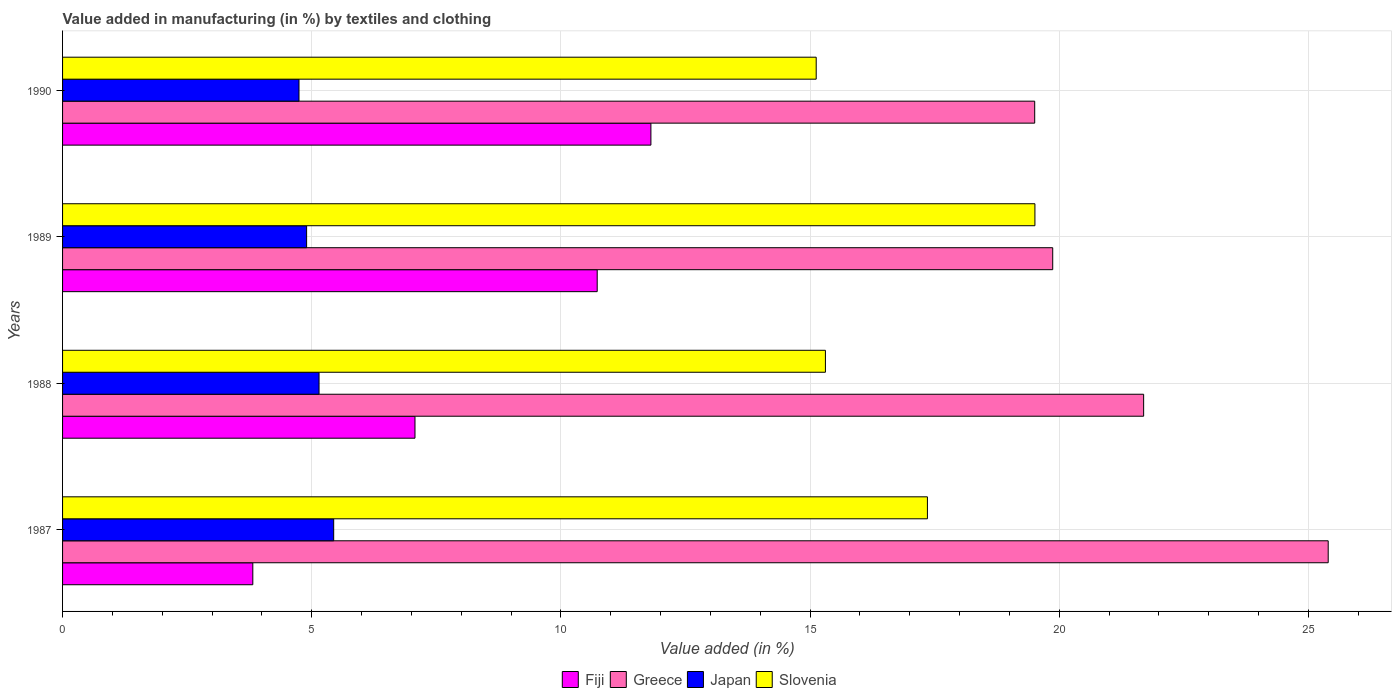How many different coloured bars are there?
Your answer should be compact. 4. How many groups of bars are there?
Your answer should be compact. 4. Are the number of bars per tick equal to the number of legend labels?
Your answer should be compact. Yes. Are the number of bars on each tick of the Y-axis equal?
Ensure brevity in your answer.  Yes. How many bars are there on the 1st tick from the top?
Your answer should be very brief. 4. How many bars are there on the 1st tick from the bottom?
Offer a terse response. 4. In how many cases, is the number of bars for a given year not equal to the number of legend labels?
Ensure brevity in your answer.  0. What is the percentage of value added in manufacturing by textiles and clothing in Fiji in 1988?
Offer a terse response. 7.07. Across all years, what is the maximum percentage of value added in manufacturing by textiles and clothing in Fiji?
Ensure brevity in your answer.  11.81. Across all years, what is the minimum percentage of value added in manufacturing by textiles and clothing in Greece?
Your response must be concise. 19.51. In which year was the percentage of value added in manufacturing by textiles and clothing in Slovenia minimum?
Make the answer very short. 1990. What is the total percentage of value added in manufacturing by textiles and clothing in Fiji in the graph?
Offer a very short reply. 33.42. What is the difference between the percentage of value added in manufacturing by textiles and clothing in Greece in 1987 and that in 1988?
Your response must be concise. 3.7. What is the difference between the percentage of value added in manufacturing by textiles and clothing in Japan in 1987 and the percentage of value added in manufacturing by textiles and clothing in Greece in 1989?
Your answer should be very brief. -14.43. What is the average percentage of value added in manufacturing by textiles and clothing in Slovenia per year?
Make the answer very short. 16.82. In the year 1987, what is the difference between the percentage of value added in manufacturing by textiles and clothing in Greece and percentage of value added in manufacturing by textiles and clothing in Slovenia?
Ensure brevity in your answer.  8.04. What is the ratio of the percentage of value added in manufacturing by textiles and clothing in Slovenia in 1987 to that in 1989?
Your answer should be very brief. 0.89. Is the percentage of value added in manufacturing by textiles and clothing in Greece in 1987 less than that in 1988?
Give a very brief answer. No. What is the difference between the highest and the second highest percentage of value added in manufacturing by textiles and clothing in Fiji?
Ensure brevity in your answer.  1.08. What is the difference between the highest and the lowest percentage of value added in manufacturing by textiles and clothing in Greece?
Make the answer very short. 5.89. What does the 1st bar from the top in 1987 represents?
Offer a terse response. Slovenia. What does the 1st bar from the bottom in 1988 represents?
Provide a short and direct response. Fiji. Is it the case that in every year, the sum of the percentage of value added in manufacturing by textiles and clothing in Fiji and percentage of value added in manufacturing by textiles and clothing in Japan is greater than the percentage of value added in manufacturing by textiles and clothing in Greece?
Offer a very short reply. No. Are all the bars in the graph horizontal?
Your answer should be compact. Yes. How many years are there in the graph?
Provide a short and direct response. 4. Does the graph contain any zero values?
Provide a succinct answer. No. Does the graph contain grids?
Ensure brevity in your answer.  Yes. How are the legend labels stacked?
Keep it short and to the point. Horizontal. What is the title of the graph?
Keep it short and to the point. Value added in manufacturing (in %) by textiles and clothing. Does "Iceland" appear as one of the legend labels in the graph?
Offer a terse response. No. What is the label or title of the X-axis?
Ensure brevity in your answer.  Value added (in %). What is the label or title of the Y-axis?
Offer a terse response. Years. What is the Value added (in %) in Fiji in 1987?
Keep it short and to the point. 3.82. What is the Value added (in %) in Greece in 1987?
Your answer should be very brief. 25.4. What is the Value added (in %) of Japan in 1987?
Provide a short and direct response. 5.44. What is the Value added (in %) of Slovenia in 1987?
Give a very brief answer. 17.35. What is the Value added (in %) in Fiji in 1988?
Keep it short and to the point. 7.07. What is the Value added (in %) of Greece in 1988?
Provide a short and direct response. 21.69. What is the Value added (in %) in Japan in 1988?
Make the answer very short. 5.15. What is the Value added (in %) in Slovenia in 1988?
Your answer should be compact. 15.31. What is the Value added (in %) of Fiji in 1989?
Your answer should be very brief. 10.73. What is the Value added (in %) of Greece in 1989?
Your answer should be very brief. 19.87. What is the Value added (in %) of Japan in 1989?
Your answer should be compact. 4.9. What is the Value added (in %) in Slovenia in 1989?
Offer a terse response. 19.51. What is the Value added (in %) in Fiji in 1990?
Make the answer very short. 11.81. What is the Value added (in %) of Greece in 1990?
Offer a terse response. 19.51. What is the Value added (in %) in Japan in 1990?
Your answer should be very brief. 4.74. What is the Value added (in %) of Slovenia in 1990?
Offer a very short reply. 15.12. Across all years, what is the maximum Value added (in %) of Fiji?
Keep it short and to the point. 11.81. Across all years, what is the maximum Value added (in %) in Greece?
Keep it short and to the point. 25.4. Across all years, what is the maximum Value added (in %) in Japan?
Give a very brief answer. 5.44. Across all years, what is the maximum Value added (in %) in Slovenia?
Offer a terse response. 19.51. Across all years, what is the minimum Value added (in %) in Fiji?
Give a very brief answer. 3.82. Across all years, what is the minimum Value added (in %) in Greece?
Make the answer very short. 19.51. Across all years, what is the minimum Value added (in %) in Japan?
Provide a short and direct response. 4.74. Across all years, what is the minimum Value added (in %) of Slovenia?
Provide a short and direct response. 15.12. What is the total Value added (in %) in Fiji in the graph?
Your answer should be very brief. 33.42. What is the total Value added (in %) of Greece in the graph?
Your answer should be very brief. 86.47. What is the total Value added (in %) of Japan in the graph?
Offer a very short reply. 20.23. What is the total Value added (in %) of Slovenia in the graph?
Keep it short and to the point. 67.3. What is the difference between the Value added (in %) in Fiji in 1987 and that in 1988?
Offer a very short reply. -3.25. What is the difference between the Value added (in %) of Greece in 1987 and that in 1988?
Offer a terse response. 3.7. What is the difference between the Value added (in %) of Japan in 1987 and that in 1988?
Provide a short and direct response. 0.29. What is the difference between the Value added (in %) in Slovenia in 1987 and that in 1988?
Keep it short and to the point. 2.05. What is the difference between the Value added (in %) of Fiji in 1987 and that in 1989?
Your response must be concise. -6.91. What is the difference between the Value added (in %) of Greece in 1987 and that in 1989?
Give a very brief answer. 5.53. What is the difference between the Value added (in %) in Japan in 1987 and that in 1989?
Offer a terse response. 0.54. What is the difference between the Value added (in %) in Slovenia in 1987 and that in 1989?
Provide a short and direct response. -2.16. What is the difference between the Value added (in %) of Fiji in 1987 and that in 1990?
Provide a short and direct response. -7.99. What is the difference between the Value added (in %) of Greece in 1987 and that in 1990?
Your answer should be compact. 5.89. What is the difference between the Value added (in %) in Japan in 1987 and that in 1990?
Offer a terse response. 0.7. What is the difference between the Value added (in %) of Slovenia in 1987 and that in 1990?
Give a very brief answer. 2.23. What is the difference between the Value added (in %) in Fiji in 1988 and that in 1989?
Provide a succinct answer. -3.66. What is the difference between the Value added (in %) in Greece in 1988 and that in 1989?
Your answer should be compact. 1.82. What is the difference between the Value added (in %) in Japan in 1988 and that in 1989?
Your response must be concise. 0.25. What is the difference between the Value added (in %) in Slovenia in 1988 and that in 1989?
Your response must be concise. -4.2. What is the difference between the Value added (in %) of Fiji in 1988 and that in 1990?
Ensure brevity in your answer.  -4.73. What is the difference between the Value added (in %) of Greece in 1988 and that in 1990?
Keep it short and to the point. 2.19. What is the difference between the Value added (in %) in Japan in 1988 and that in 1990?
Provide a succinct answer. 0.4. What is the difference between the Value added (in %) in Slovenia in 1988 and that in 1990?
Give a very brief answer. 0.18. What is the difference between the Value added (in %) in Fiji in 1989 and that in 1990?
Your answer should be compact. -1.08. What is the difference between the Value added (in %) in Greece in 1989 and that in 1990?
Keep it short and to the point. 0.36. What is the difference between the Value added (in %) of Japan in 1989 and that in 1990?
Your answer should be compact. 0.15. What is the difference between the Value added (in %) of Slovenia in 1989 and that in 1990?
Offer a very short reply. 4.39. What is the difference between the Value added (in %) of Fiji in 1987 and the Value added (in %) of Greece in 1988?
Offer a terse response. -17.88. What is the difference between the Value added (in %) of Fiji in 1987 and the Value added (in %) of Japan in 1988?
Offer a terse response. -1.33. What is the difference between the Value added (in %) in Fiji in 1987 and the Value added (in %) in Slovenia in 1988?
Your response must be concise. -11.49. What is the difference between the Value added (in %) of Greece in 1987 and the Value added (in %) of Japan in 1988?
Your answer should be compact. 20.25. What is the difference between the Value added (in %) in Greece in 1987 and the Value added (in %) in Slovenia in 1988?
Offer a very short reply. 10.09. What is the difference between the Value added (in %) in Japan in 1987 and the Value added (in %) in Slovenia in 1988?
Provide a succinct answer. -9.87. What is the difference between the Value added (in %) in Fiji in 1987 and the Value added (in %) in Greece in 1989?
Give a very brief answer. -16.05. What is the difference between the Value added (in %) of Fiji in 1987 and the Value added (in %) of Japan in 1989?
Offer a terse response. -1.08. What is the difference between the Value added (in %) of Fiji in 1987 and the Value added (in %) of Slovenia in 1989?
Your answer should be very brief. -15.69. What is the difference between the Value added (in %) of Greece in 1987 and the Value added (in %) of Japan in 1989?
Your answer should be very brief. 20.5. What is the difference between the Value added (in %) in Greece in 1987 and the Value added (in %) in Slovenia in 1989?
Ensure brevity in your answer.  5.89. What is the difference between the Value added (in %) of Japan in 1987 and the Value added (in %) of Slovenia in 1989?
Make the answer very short. -14.07. What is the difference between the Value added (in %) in Fiji in 1987 and the Value added (in %) in Greece in 1990?
Make the answer very short. -15.69. What is the difference between the Value added (in %) in Fiji in 1987 and the Value added (in %) in Japan in 1990?
Keep it short and to the point. -0.93. What is the difference between the Value added (in %) in Fiji in 1987 and the Value added (in %) in Slovenia in 1990?
Offer a very short reply. -11.31. What is the difference between the Value added (in %) in Greece in 1987 and the Value added (in %) in Japan in 1990?
Your response must be concise. 20.65. What is the difference between the Value added (in %) in Greece in 1987 and the Value added (in %) in Slovenia in 1990?
Offer a terse response. 10.27. What is the difference between the Value added (in %) in Japan in 1987 and the Value added (in %) in Slovenia in 1990?
Your answer should be very brief. -9.68. What is the difference between the Value added (in %) of Fiji in 1988 and the Value added (in %) of Greece in 1989?
Provide a short and direct response. -12.8. What is the difference between the Value added (in %) in Fiji in 1988 and the Value added (in %) in Japan in 1989?
Your answer should be compact. 2.17. What is the difference between the Value added (in %) of Fiji in 1988 and the Value added (in %) of Slovenia in 1989?
Offer a terse response. -12.44. What is the difference between the Value added (in %) in Greece in 1988 and the Value added (in %) in Japan in 1989?
Make the answer very short. 16.8. What is the difference between the Value added (in %) of Greece in 1988 and the Value added (in %) of Slovenia in 1989?
Your answer should be very brief. 2.18. What is the difference between the Value added (in %) of Japan in 1988 and the Value added (in %) of Slovenia in 1989?
Your answer should be very brief. -14.37. What is the difference between the Value added (in %) in Fiji in 1988 and the Value added (in %) in Greece in 1990?
Provide a short and direct response. -12.44. What is the difference between the Value added (in %) in Fiji in 1988 and the Value added (in %) in Japan in 1990?
Provide a succinct answer. 2.33. What is the difference between the Value added (in %) of Fiji in 1988 and the Value added (in %) of Slovenia in 1990?
Ensure brevity in your answer.  -8.05. What is the difference between the Value added (in %) in Greece in 1988 and the Value added (in %) in Japan in 1990?
Offer a terse response. 16.95. What is the difference between the Value added (in %) in Greece in 1988 and the Value added (in %) in Slovenia in 1990?
Your answer should be very brief. 6.57. What is the difference between the Value added (in %) of Japan in 1988 and the Value added (in %) of Slovenia in 1990?
Give a very brief answer. -9.98. What is the difference between the Value added (in %) of Fiji in 1989 and the Value added (in %) of Greece in 1990?
Make the answer very short. -8.78. What is the difference between the Value added (in %) of Fiji in 1989 and the Value added (in %) of Japan in 1990?
Offer a terse response. 5.98. What is the difference between the Value added (in %) in Fiji in 1989 and the Value added (in %) in Slovenia in 1990?
Your answer should be compact. -4.39. What is the difference between the Value added (in %) in Greece in 1989 and the Value added (in %) in Japan in 1990?
Your response must be concise. 15.12. What is the difference between the Value added (in %) of Greece in 1989 and the Value added (in %) of Slovenia in 1990?
Your answer should be very brief. 4.75. What is the difference between the Value added (in %) of Japan in 1989 and the Value added (in %) of Slovenia in 1990?
Make the answer very short. -10.23. What is the average Value added (in %) in Fiji per year?
Offer a terse response. 8.36. What is the average Value added (in %) of Greece per year?
Offer a very short reply. 21.62. What is the average Value added (in %) in Japan per year?
Your answer should be compact. 5.06. What is the average Value added (in %) in Slovenia per year?
Give a very brief answer. 16.82. In the year 1987, what is the difference between the Value added (in %) in Fiji and Value added (in %) in Greece?
Make the answer very short. -21.58. In the year 1987, what is the difference between the Value added (in %) in Fiji and Value added (in %) in Japan?
Make the answer very short. -1.62. In the year 1987, what is the difference between the Value added (in %) of Fiji and Value added (in %) of Slovenia?
Offer a very short reply. -13.54. In the year 1987, what is the difference between the Value added (in %) of Greece and Value added (in %) of Japan?
Make the answer very short. 19.96. In the year 1987, what is the difference between the Value added (in %) of Greece and Value added (in %) of Slovenia?
Keep it short and to the point. 8.04. In the year 1987, what is the difference between the Value added (in %) of Japan and Value added (in %) of Slovenia?
Provide a succinct answer. -11.91. In the year 1988, what is the difference between the Value added (in %) in Fiji and Value added (in %) in Greece?
Ensure brevity in your answer.  -14.62. In the year 1988, what is the difference between the Value added (in %) in Fiji and Value added (in %) in Japan?
Offer a terse response. 1.93. In the year 1988, what is the difference between the Value added (in %) of Fiji and Value added (in %) of Slovenia?
Provide a succinct answer. -8.24. In the year 1988, what is the difference between the Value added (in %) of Greece and Value added (in %) of Japan?
Give a very brief answer. 16.55. In the year 1988, what is the difference between the Value added (in %) in Greece and Value added (in %) in Slovenia?
Ensure brevity in your answer.  6.39. In the year 1988, what is the difference between the Value added (in %) in Japan and Value added (in %) in Slovenia?
Ensure brevity in your answer.  -10.16. In the year 1989, what is the difference between the Value added (in %) in Fiji and Value added (in %) in Greece?
Provide a succinct answer. -9.14. In the year 1989, what is the difference between the Value added (in %) of Fiji and Value added (in %) of Japan?
Your answer should be compact. 5.83. In the year 1989, what is the difference between the Value added (in %) of Fiji and Value added (in %) of Slovenia?
Provide a short and direct response. -8.78. In the year 1989, what is the difference between the Value added (in %) of Greece and Value added (in %) of Japan?
Offer a very short reply. 14.97. In the year 1989, what is the difference between the Value added (in %) of Greece and Value added (in %) of Slovenia?
Make the answer very short. 0.36. In the year 1989, what is the difference between the Value added (in %) of Japan and Value added (in %) of Slovenia?
Offer a terse response. -14.61. In the year 1990, what is the difference between the Value added (in %) in Fiji and Value added (in %) in Greece?
Offer a terse response. -7.7. In the year 1990, what is the difference between the Value added (in %) in Fiji and Value added (in %) in Japan?
Your response must be concise. 7.06. In the year 1990, what is the difference between the Value added (in %) of Fiji and Value added (in %) of Slovenia?
Keep it short and to the point. -3.32. In the year 1990, what is the difference between the Value added (in %) of Greece and Value added (in %) of Japan?
Provide a short and direct response. 14.76. In the year 1990, what is the difference between the Value added (in %) in Greece and Value added (in %) in Slovenia?
Provide a succinct answer. 4.38. In the year 1990, what is the difference between the Value added (in %) in Japan and Value added (in %) in Slovenia?
Keep it short and to the point. -10.38. What is the ratio of the Value added (in %) in Fiji in 1987 to that in 1988?
Offer a terse response. 0.54. What is the ratio of the Value added (in %) in Greece in 1987 to that in 1988?
Your response must be concise. 1.17. What is the ratio of the Value added (in %) in Japan in 1987 to that in 1988?
Offer a terse response. 1.06. What is the ratio of the Value added (in %) in Slovenia in 1987 to that in 1988?
Make the answer very short. 1.13. What is the ratio of the Value added (in %) of Fiji in 1987 to that in 1989?
Offer a very short reply. 0.36. What is the ratio of the Value added (in %) in Greece in 1987 to that in 1989?
Provide a short and direct response. 1.28. What is the ratio of the Value added (in %) in Japan in 1987 to that in 1989?
Your answer should be very brief. 1.11. What is the ratio of the Value added (in %) in Slovenia in 1987 to that in 1989?
Your answer should be very brief. 0.89. What is the ratio of the Value added (in %) in Fiji in 1987 to that in 1990?
Your answer should be compact. 0.32. What is the ratio of the Value added (in %) of Greece in 1987 to that in 1990?
Make the answer very short. 1.3. What is the ratio of the Value added (in %) in Japan in 1987 to that in 1990?
Offer a very short reply. 1.15. What is the ratio of the Value added (in %) of Slovenia in 1987 to that in 1990?
Offer a very short reply. 1.15. What is the ratio of the Value added (in %) in Fiji in 1988 to that in 1989?
Your answer should be compact. 0.66. What is the ratio of the Value added (in %) in Greece in 1988 to that in 1989?
Make the answer very short. 1.09. What is the ratio of the Value added (in %) of Japan in 1988 to that in 1989?
Provide a succinct answer. 1.05. What is the ratio of the Value added (in %) in Slovenia in 1988 to that in 1989?
Provide a short and direct response. 0.78. What is the ratio of the Value added (in %) in Fiji in 1988 to that in 1990?
Your answer should be compact. 0.6. What is the ratio of the Value added (in %) in Greece in 1988 to that in 1990?
Provide a short and direct response. 1.11. What is the ratio of the Value added (in %) of Japan in 1988 to that in 1990?
Give a very brief answer. 1.08. What is the ratio of the Value added (in %) in Slovenia in 1988 to that in 1990?
Ensure brevity in your answer.  1.01. What is the ratio of the Value added (in %) of Fiji in 1989 to that in 1990?
Provide a succinct answer. 0.91. What is the ratio of the Value added (in %) of Greece in 1989 to that in 1990?
Ensure brevity in your answer.  1.02. What is the ratio of the Value added (in %) in Japan in 1989 to that in 1990?
Ensure brevity in your answer.  1.03. What is the ratio of the Value added (in %) of Slovenia in 1989 to that in 1990?
Your response must be concise. 1.29. What is the difference between the highest and the second highest Value added (in %) of Fiji?
Make the answer very short. 1.08. What is the difference between the highest and the second highest Value added (in %) of Greece?
Your response must be concise. 3.7. What is the difference between the highest and the second highest Value added (in %) in Japan?
Provide a succinct answer. 0.29. What is the difference between the highest and the second highest Value added (in %) in Slovenia?
Provide a short and direct response. 2.16. What is the difference between the highest and the lowest Value added (in %) of Fiji?
Your answer should be very brief. 7.99. What is the difference between the highest and the lowest Value added (in %) of Greece?
Ensure brevity in your answer.  5.89. What is the difference between the highest and the lowest Value added (in %) of Japan?
Provide a succinct answer. 0.7. What is the difference between the highest and the lowest Value added (in %) of Slovenia?
Provide a succinct answer. 4.39. 